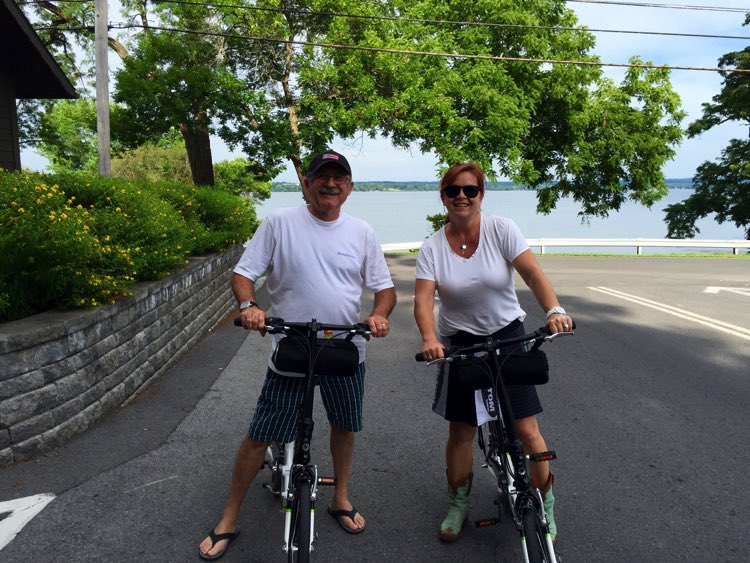What might the weather be like in this image, and how suitable is it for cycling? The image shows a clear sky with ample sunlight, suggesting a warm and pleasant day, which is ideal for outdoor activities like cycling. The riders are dressed in light clothing, indicating comfortable temperatures for a leisurely ride. 